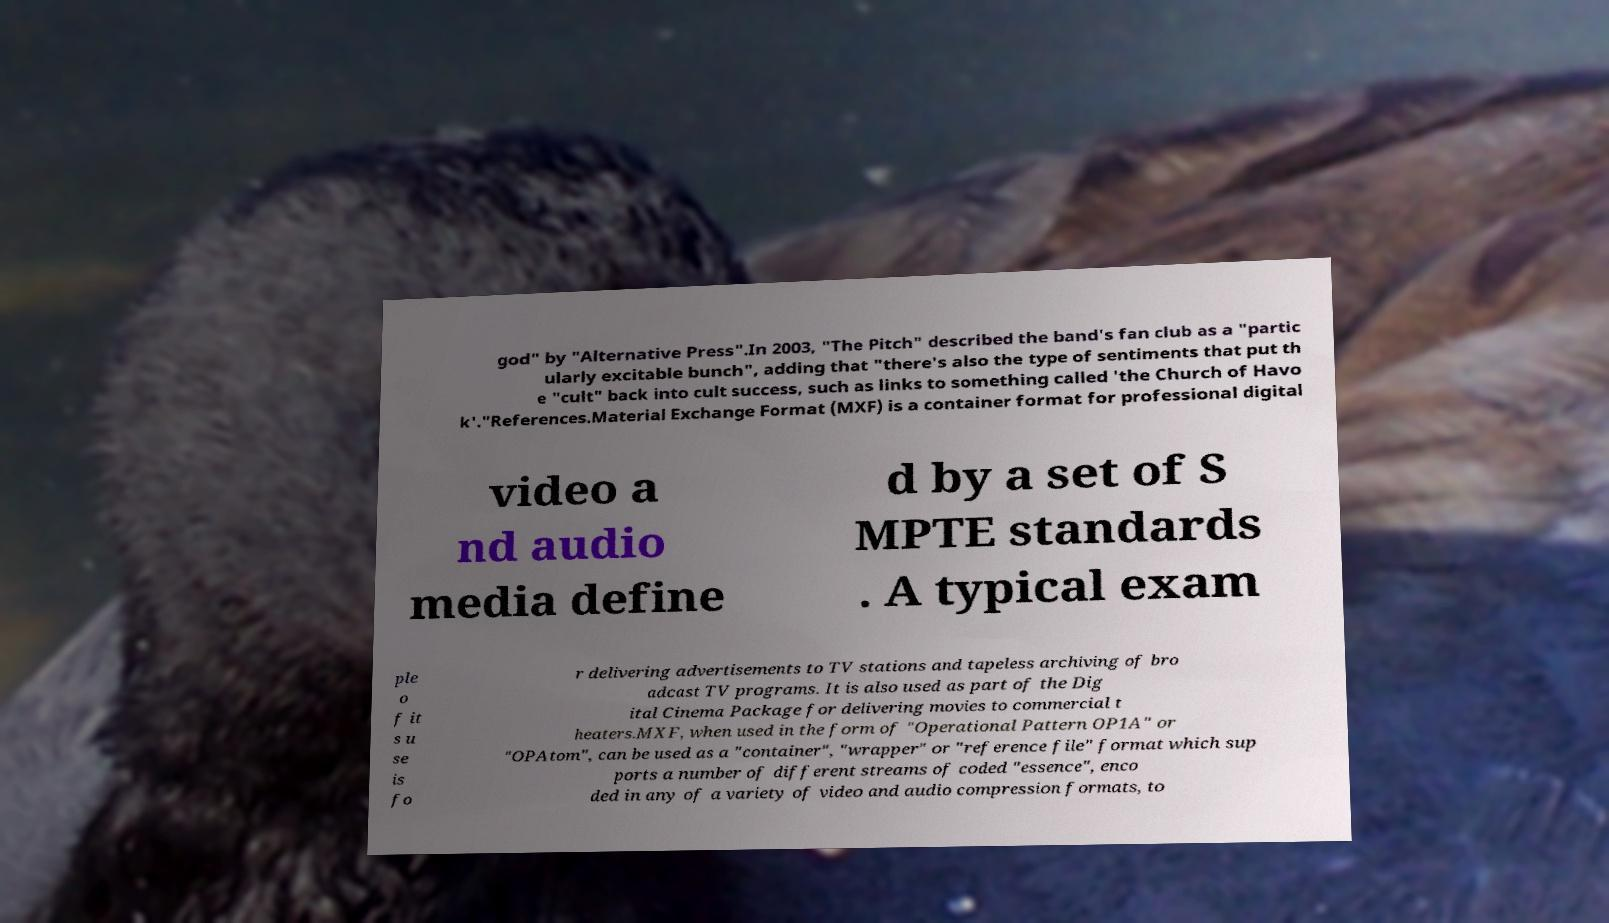There's text embedded in this image that I need extracted. Can you transcribe it verbatim? god" by "Alternative Press".In 2003, "The Pitch" described the band's fan club as a "partic ularly excitable bunch", adding that "there's also the type of sentiments that put th e "cult" back into cult success, such as links to something called 'the Church of Havo k'."References.Material Exchange Format (MXF) is a container format for professional digital video a nd audio media define d by a set of S MPTE standards . A typical exam ple o f it s u se is fo r delivering advertisements to TV stations and tapeless archiving of bro adcast TV programs. It is also used as part of the Dig ital Cinema Package for delivering movies to commercial t heaters.MXF, when used in the form of "Operational Pattern OP1A" or "OPAtom", can be used as a "container", "wrapper" or "reference file" format which sup ports a number of different streams of coded "essence", enco ded in any of a variety of video and audio compression formats, to 